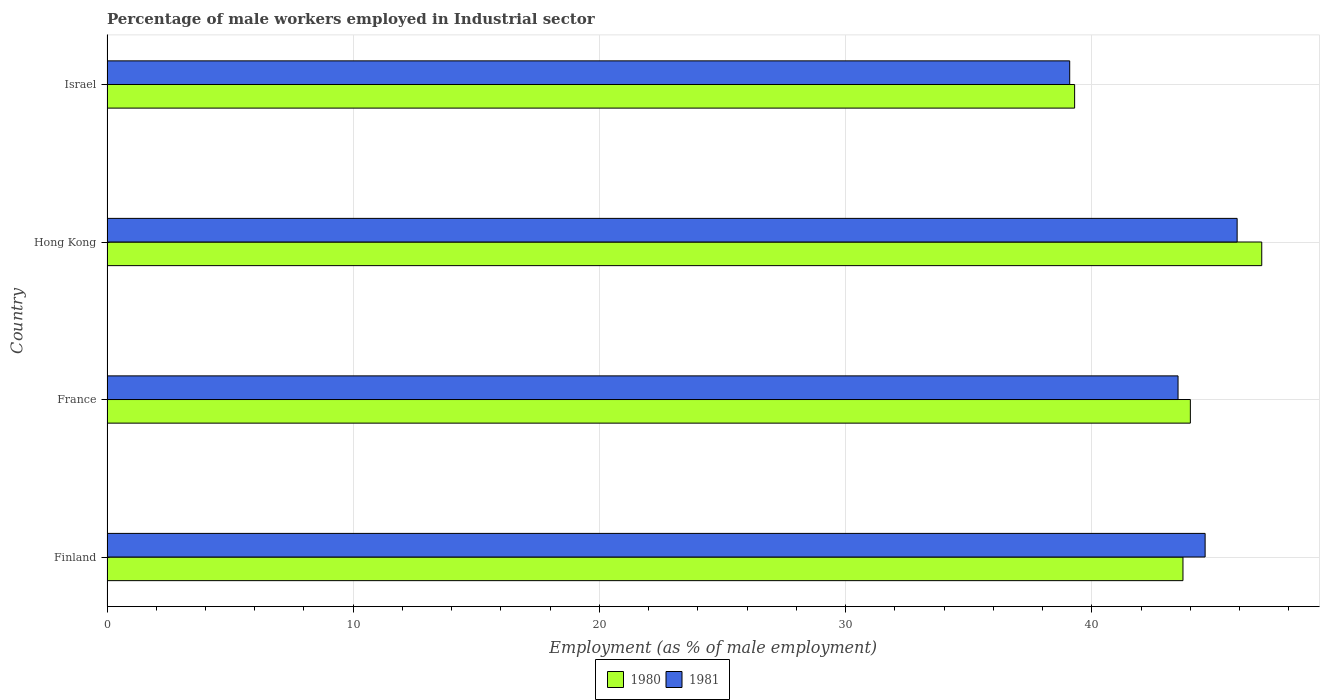How many different coloured bars are there?
Provide a succinct answer. 2. How many groups of bars are there?
Provide a succinct answer. 4. Are the number of bars on each tick of the Y-axis equal?
Your answer should be compact. Yes. What is the label of the 1st group of bars from the top?
Make the answer very short. Israel. In how many cases, is the number of bars for a given country not equal to the number of legend labels?
Give a very brief answer. 0. What is the percentage of male workers employed in Industrial sector in 1981 in Hong Kong?
Your answer should be compact. 45.9. Across all countries, what is the maximum percentage of male workers employed in Industrial sector in 1980?
Offer a very short reply. 46.9. Across all countries, what is the minimum percentage of male workers employed in Industrial sector in 1981?
Your answer should be compact. 39.1. In which country was the percentage of male workers employed in Industrial sector in 1981 maximum?
Offer a terse response. Hong Kong. In which country was the percentage of male workers employed in Industrial sector in 1980 minimum?
Offer a terse response. Israel. What is the total percentage of male workers employed in Industrial sector in 1981 in the graph?
Your response must be concise. 173.1. What is the difference between the percentage of male workers employed in Industrial sector in 1981 in Finland and that in France?
Give a very brief answer. 1.1. What is the difference between the percentage of male workers employed in Industrial sector in 1980 in Finland and the percentage of male workers employed in Industrial sector in 1981 in Israel?
Provide a short and direct response. 4.6. What is the average percentage of male workers employed in Industrial sector in 1980 per country?
Provide a short and direct response. 43.48. What is the difference between the percentage of male workers employed in Industrial sector in 1980 and percentage of male workers employed in Industrial sector in 1981 in Finland?
Your answer should be compact. -0.9. In how many countries, is the percentage of male workers employed in Industrial sector in 1981 greater than 30 %?
Give a very brief answer. 4. What is the ratio of the percentage of male workers employed in Industrial sector in 1981 in Finland to that in Israel?
Make the answer very short. 1.14. Is the percentage of male workers employed in Industrial sector in 1981 in France less than that in Hong Kong?
Your answer should be very brief. Yes. Is the difference between the percentage of male workers employed in Industrial sector in 1980 in Finland and France greater than the difference between the percentage of male workers employed in Industrial sector in 1981 in Finland and France?
Give a very brief answer. No. What is the difference between the highest and the second highest percentage of male workers employed in Industrial sector in 1981?
Your answer should be very brief. 1.3. What is the difference between the highest and the lowest percentage of male workers employed in Industrial sector in 1981?
Your response must be concise. 6.8. In how many countries, is the percentage of male workers employed in Industrial sector in 1981 greater than the average percentage of male workers employed in Industrial sector in 1981 taken over all countries?
Provide a short and direct response. 3. Is the sum of the percentage of male workers employed in Industrial sector in 1981 in France and Israel greater than the maximum percentage of male workers employed in Industrial sector in 1980 across all countries?
Offer a terse response. Yes. What does the 1st bar from the top in Israel represents?
Ensure brevity in your answer.  1981. What does the 2nd bar from the bottom in Israel represents?
Your response must be concise. 1981. How many bars are there?
Keep it short and to the point. 8. Are all the bars in the graph horizontal?
Your answer should be very brief. Yes. How many countries are there in the graph?
Provide a short and direct response. 4. Are the values on the major ticks of X-axis written in scientific E-notation?
Your answer should be very brief. No. Does the graph contain any zero values?
Your answer should be compact. No. Does the graph contain grids?
Make the answer very short. Yes. How many legend labels are there?
Provide a succinct answer. 2. How are the legend labels stacked?
Your answer should be compact. Horizontal. What is the title of the graph?
Your answer should be very brief. Percentage of male workers employed in Industrial sector. What is the label or title of the X-axis?
Your response must be concise. Employment (as % of male employment). What is the label or title of the Y-axis?
Offer a terse response. Country. What is the Employment (as % of male employment) in 1980 in Finland?
Your response must be concise. 43.7. What is the Employment (as % of male employment) in 1981 in Finland?
Make the answer very short. 44.6. What is the Employment (as % of male employment) in 1981 in France?
Your answer should be compact. 43.5. What is the Employment (as % of male employment) of 1980 in Hong Kong?
Keep it short and to the point. 46.9. What is the Employment (as % of male employment) of 1981 in Hong Kong?
Your response must be concise. 45.9. What is the Employment (as % of male employment) in 1980 in Israel?
Keep it short and to the point. 39.3. What is the Employment (as % of male employment) in 1981 in Israel?
Provide a succinct answer. 39.1. Across all countries, what is the maximum Employment (as % of male employment) in 1980?
Provide a succinct answer. 46.9. Across all countries, what is the maximum Employment (as % of male employment) in 1981?
Offer a very short reply. 45.9. Across all countries, what is the minimum Employment (as % of male employment) in 1980?
Ensure brevity in your answer.  39.3. Across all countries, what is the minimum Employment (as % of male employment) of 1981?
Offer a very short reply. 39.1. What is the total Employment (as % of male employment) in 1980 in the graph?
Provide a succinct answer. 173.9. What is the total Employment (as % of male employment) of 1981 in the graph?
Make the answer very short. 173.1. What is the difference between the Employment (as % of male employment) of 1981 in Finland and that in France?
Offer a terse response. 1.1. What is the difference between the Employment (as % of male employment) in 1980 in Finland and that in Hong Kong?
Provide a succinct answer. -3.2. What is the difference between the Employment (as % of male employment) in 1981 in Finland and that in Hong Kong?
Give a very brief answer. -1.3. What is the difference between the Employment (as % of male employment) of 1980 in Finland and that in Israel?
Provide a succinct answer. 4.4. What is the difference between the Employment (as % of male employment) of 1981 in Hong Kong and that in Israel?
Your answer should be compact. 6.8. What is the difference between the Employment (as % of male employment) in 1980 in Finland and the Employment (as % of male employment) in 1981 in France?
Provide a succinct answer. 0.2. What is the difference between the Employment (as % of male employment) in 1980 in Finland and the Employment (as % of male employment) in 1981 in Hong Kong?
Offer a very short reply. -2.2. What is the difference between the Employment (as % of male employment) of 1980 in Finland and the Employment (as % of male employment) of 1981 in Israel?
Offer a very short reply. 4.6. What is the difference between the Employment (as % of male employment) of 1980 in France and the Employment (as % of male employment) of 1981 in Israel?
Your answer should be very brief. 4.9. What is the average Employment (as % of male employment) of 1980 per country?
Offer a very short reply. 43.48. What is the average Employment (as % of male employment) of 1981 per country?
Offer a terse response. 43.27. What is the difference between the Employment (as % of male employment) of 1980 and Employment (as % of male employment) of 1981 in Hong Kong?
Give a very brief answer. 1. What is the ratio of the Employment (as % of male employment) of 1981 in Finland to that in France?
Your response must be concise. 1.03. What is the ratio of the Employment (as % of male employment) in 1980 in Finland to that in Hong Kong?
Offer a very short reply. 0.93. What is the ratio of the Employment (as % of male employment) in 1981 in Finland to that in Hong Kong?
Keep it short and to the point. 0.97. What is the ratio of the Employment (as % of male employment) in 1980 in Finland to that in Israel?
Your answer should be very brief. 1.11. What is the ratio of the Employment (as % of male employment) in 1981 in Finland to that in Israel?
Your answer should be compact. 1.14. What is the ratio of the Employment (as % of male employment) of 1980 in France to that in Hong Kong?
Offer a terse response. 0.94. What is the ratio of the Employment (as % of male employment) of 1981 in France to that in Hong Kong?
Your answer should be compact. 0.95. What is the ratio of the Employment (as % of male employment) of 1980 in France to that in Israel?
Offer a terse response. 1.12. What is the ratio of the Employment (as % of male employment) in 1981 in France to that in Israel?
Make the answer very short. 1.11. What is the ratio of the Employment (as % of male employment) of 1980 in Hong Kong to that in Israel?
Your response must be concise. 1.19. What is the ratio of the Employment (as % of male employment) of 1981 in Hong Kong to that in Israel?
Your answer should be very brief. 1.17. What is the difference between the highest and the second highest Employment (as % of male employment) of 1980?
Your answer should be compact. 2.9. 